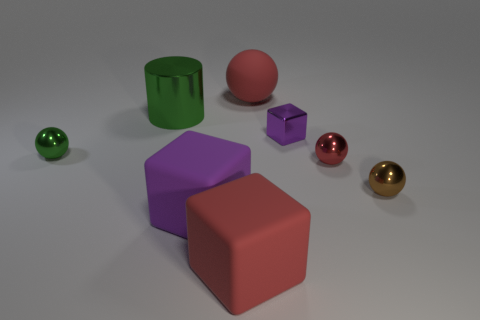Add 1 tiny purple objects. How many objects exist? 9 Subtract all green balls. How many balls are left? 3 Subtract all brown spheres. How many spheres are left? 3 Subtract all red spheres. How many red cubes are left? 1 Subtract all large cylinders. Subtract all small shiny blocks. How many objects are left? 6 Add 1 small shiny things. How many small shiny things are left? 5 Add 7 red things. How many red things exist? 10 Subtract 0 blue cubes. How many objects are left? 8 Subtract all cubes. How many objects are left? 5 Subtract 1 cylinders. How many cylinders are left? 0 